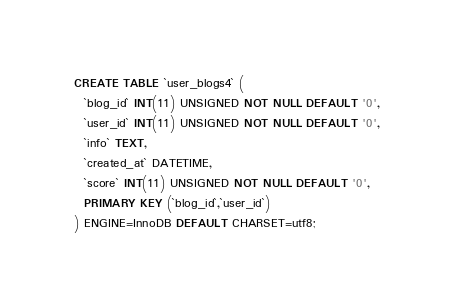Convert code to text. <code><loc_0><loc_0><loc_500><loc_500><_SQL_>CREATE TABLE `user_blogs4` (
  `blog_id` INT(11) UNSIGNED NOT NULL DEFAULT '0',
  `user_id` INT(11) UNSIGNED NOT NULL DEFAULT '0',
  `info` TEXT,
  `created_at` DATETIME,
  `score` INT(11) UNSIGNED NOT NULL DEFAULT '0',
  PRIMARY KEY (`blog_id`,`user_id`)
) ENGINE=InnoDB DEFAULT CHARSET=utf8;
</code> 